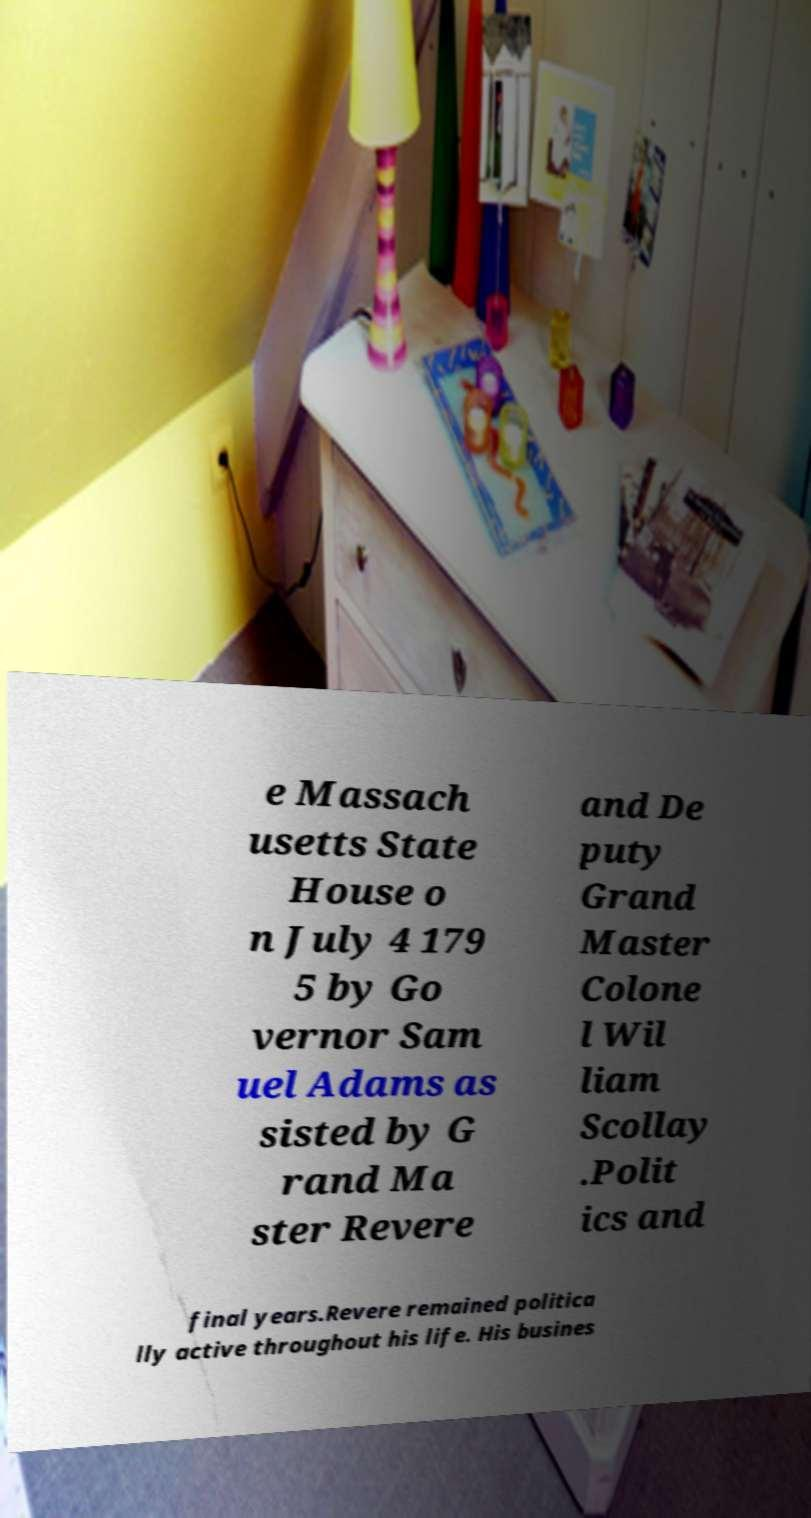Could you extract and type out the text from this image? e Massach usetts State House o n July 4 179 5 by Go vernor Sam uel Adams as sisted by G rand Ma ster Revere and De puty Grand Master Colone l Wil liam Scollay .Polit ics and final years.Revere remained politica lly active throughout his life. His busines 